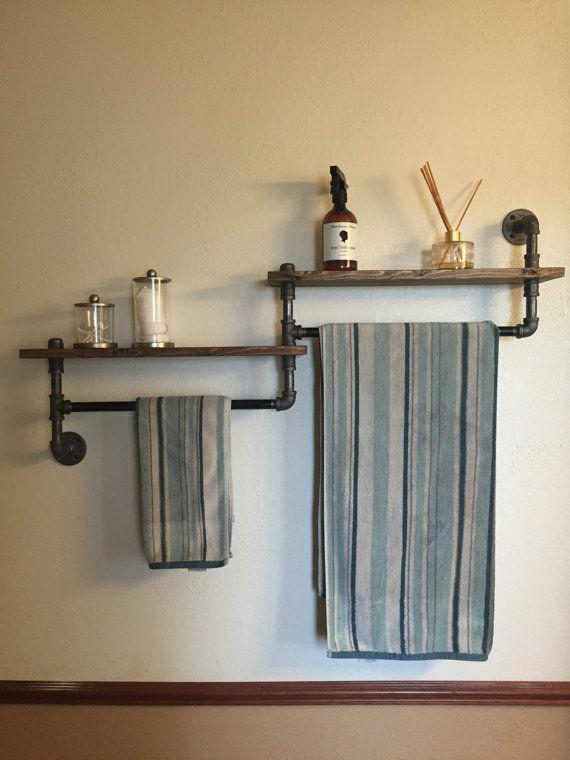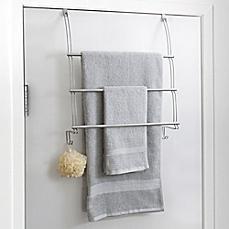The first image is the image on the left, the second image is the image on the right. Examine the images to the left and right. Is the description "One of the racks has nothing on it." accurate? Answer yes or no. No. 